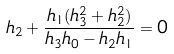Convert formula to latex. <formula><loc_0><loc_0><loc_500><loc_500>h _ { 2 } + \frac { h _ { 1 } ( h _ { 3 } ^ { 2 } + h _ { 2 } ^ { 2 } ) } { h _ { 3 } h _ { 0 } - h _ { 2 } h _ { 1 } } = 0</formula> 